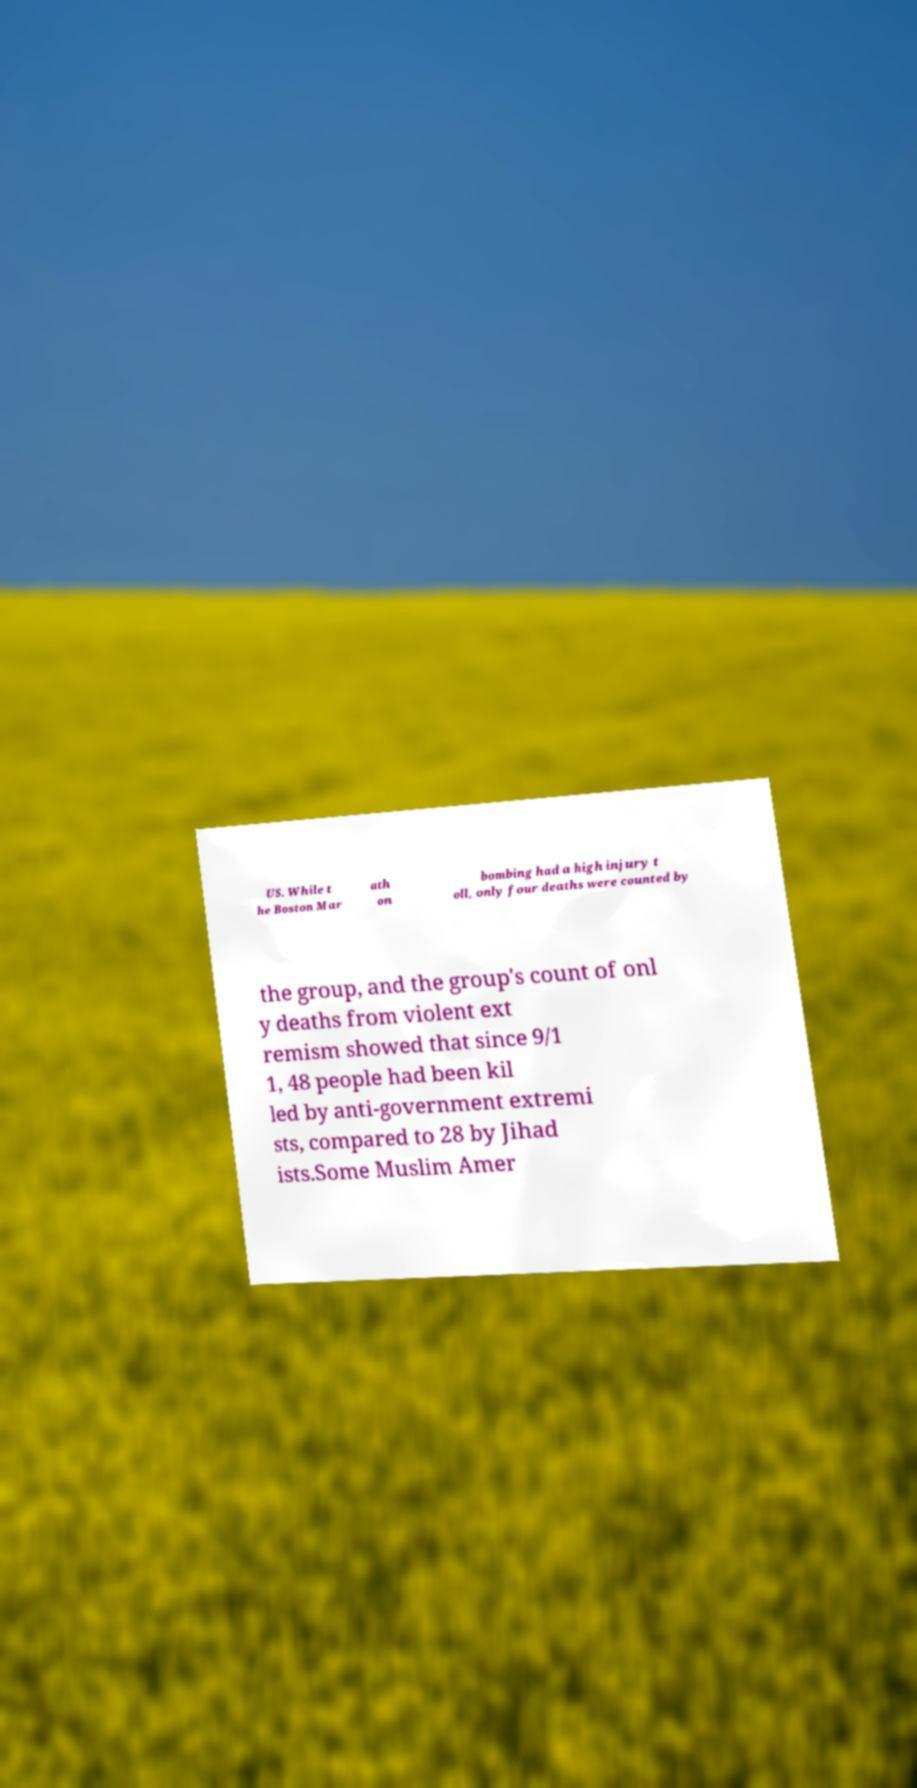Please read and relay the text visible in this image. What does it say? US. While t he Boston Mar ath on bombing had a high injury t oll, only four deaths were counted by the group, and the group's count of onl y deaths from violent ext remism showed that since 9/1 1, 48 people had been kil led by anti-government extremi sts, compared to 28 by Jihad ists.Some Muslim Amer 